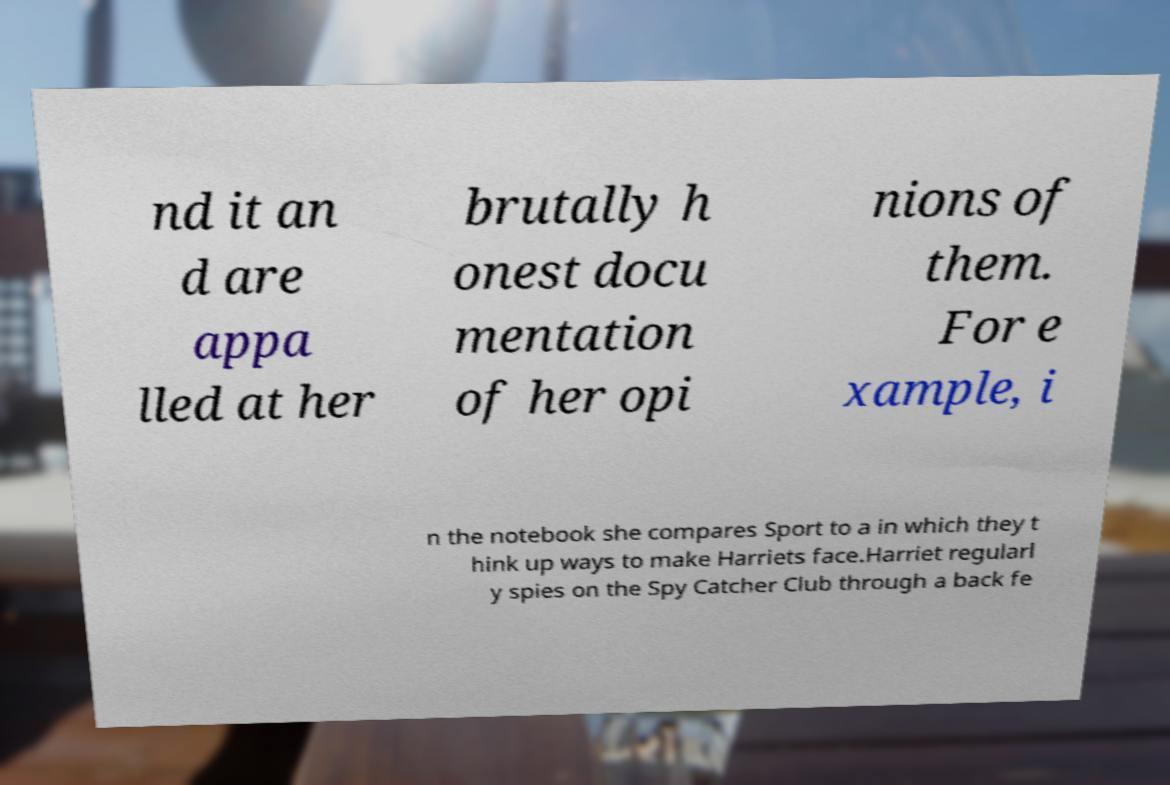I need the written content from this picture converted into text. Can you do that? nd it an d are appa lled at her brutally h onest docu mentation of her opi nions of them. For e xample, i n the notebook she compares Sport to a in which they t hink up ways to make Harriets face.Harriet regularl y spies on the Spy Catcher Club through a back fe 